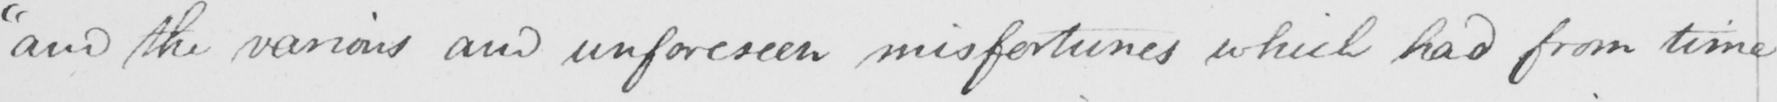Transcribe the text shown in this historical manuscript line. " and the various and unforeseen misfortunes which had from time 